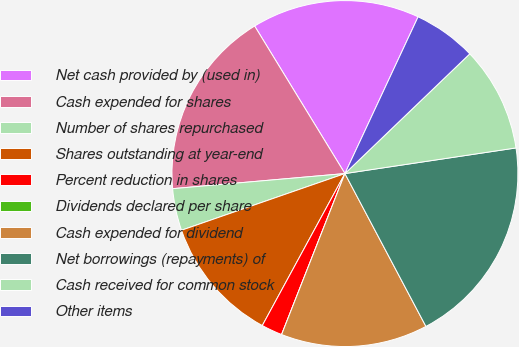Convert chart. <chart><loc_0><loc_0><loc_500><loc_500><pie_chart><fcel>Net cash provided by (used in)<fcel>Cash expended for shares<fcel>Number of shares repurchased<fcel>Shares outstanding at year-end<fcel>Percent reduction in shares<fcel>Dividends declared per share<fcel>Cash expended for dividend<fcel>Net borrowings (repayments) of<fcel>Cash received for common stock<fcel>Other items<nl><fcel>15.69%<fcel>17.65%<fcel>3.92%<fcel>11.76%<fcel>1.96%<fcel>0.0%<fcel>13.72%<fcel>19.61%<fcel>9.8%<fcel>5.88%<nl></chart> 